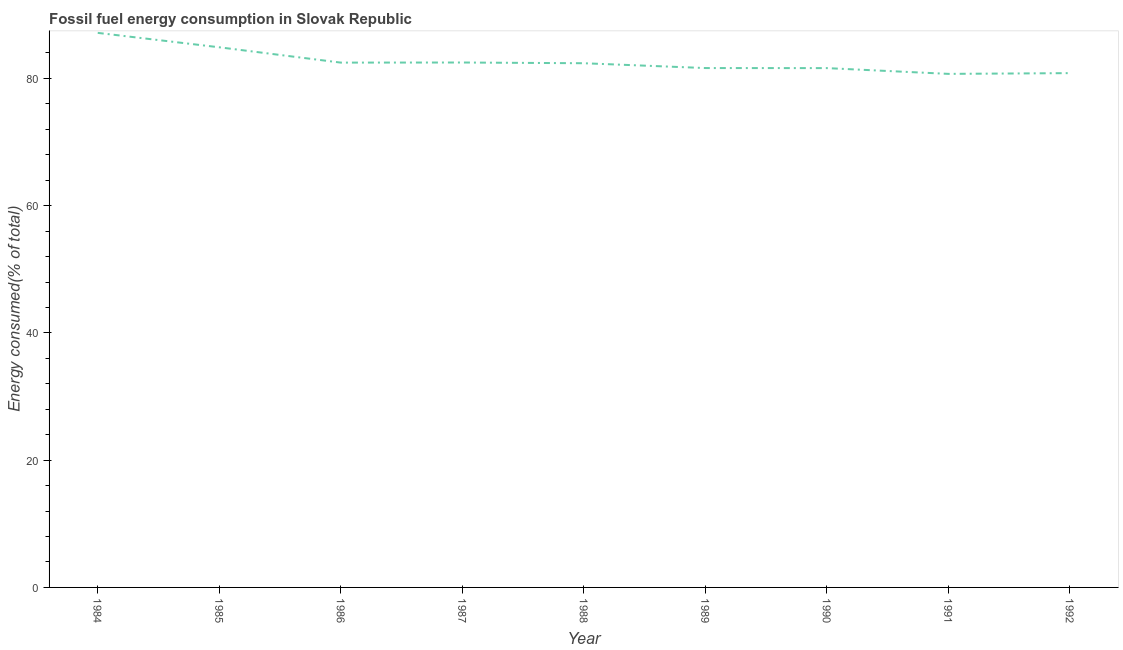What is the fossil fuel energy consumption in 1990?
Provide a succinct answer. 81.62. Across all years, what is the maximum fossil fuel energy consumption?
Give a very brief answer. 87.16. Across all years, what is the minimum fossil fuel energy consumption?
Keep it short and to the point. 80.72. In which year was the fossil fuel energy consumption maximum?
Provide a short and direct response. 1984. In which year was the fossil fuel energy consumption minimum?
Offer a very short reply. 1991. What is the sum of the fossil fuel energy consumption?
Ensure brevity in your answer.  744.24. What is the difference between the fossil fuel energy consumption in 1987 and 1992?
Give a very brief answer. 1.67. What is the average fossil fuel energy consumption per year?
Your response must be concise. 82.69. What is the median fossil fuel energy consumption?
Ensure brevity in your answer.  82.39. Do a majority of the years between 1989 and 1992 (inclusive) have fossil fuel energy consumption greater than 64 %?
Ensure brevity in your answer.  Yes. What is the ratio of the fossil fuel energy consumption in 1985 to that in 1988?
Offer a very short reply. 1.03. Is the fossil fuel energy consumption in 1988 less than that in 1989?
Provide a short and direct response. No. Is the difference between the fossil fuel energy consumption in 1987 and 1989 greater than the difference between any two years?
Your answer should be compact. No. What is the difference between the highest and the second highest fossil fuel energy consumption?
Make the answer very short. 2.27. What is the difference between the highest and the lowest fossil fuel energy consumption?
Provide a short and direct response. 6.44. Does the fossil fuel energy consumption monotonically increase over the years?
Offer a very short reply. No. How many lines are there?
Provide a succinct answer. 1. How many years are there in the graph?
Give a very brief answer. 9. What is the difference between two consecutive major ticks on the Y-axis?
Your answer should be very brief. 20. Does the graph contain any zero values?
Give a very brief answer. No. What is the title of the graph?
Your answer should be compact. Fossil fuel energy consumption in Slovak Republic. What is the label or title of the X-axis?
Give a very brief answer. Year. What is the label or title of the Y-axis?
Offer a very short reply. Energy consumed(% of total). What is the Energy consumed(% of total) in 1984?
Offer a very short reply. 87.16. What is the Energy consumed(% of total) in 1985?
Provide a succinct answer. 84.9. What is the Energy consumed(% of total) in 1986?
Make the answer very short. 82.49. What is the Energy consumed(% of total) of 1987?
Offer a terse response. 82.5. What is the Energy consumed(% of total) in 1988?
Your response must be concise. 82.39. What is the Energy consumed(% of total) in 1989?
Your response must be concise. 81.63. What is the Energy consumed(% of total) of 1990?
Provide a succinct answer. 81.62. What is the Energy consumed(% of total) in 1991?
Make the answer very short. 80.72. What is the Energy consumed(% of total) in 1992?
Provide a succinct answer. 80.83. What is the difference between the Energy consumed(% of total) in 1984 and 1985?
Make the answer very short. 2.27. What is the difference between the Energy consumed(% of total) in 1984 and 1986?
Make the answer very short. 4.67. What is the difference between the Energy consumed(% of total) in 1984 and 1987?
Ensure brevity in your answer.  4.66. What is the difference between the Energy consumed(% of total) in 1984 and 1988?
Your response must be concise. 4.77. What is the difference between the Energy consumed(% of total) in 1984 and 1989?
Give a very brief answer. 5.53. What is the difference between the Energy consumed(% of total) in 1984 and 1990?
Make the answer very short. 5.54. What is the difference between the Energy consumed(% of total) in 1984 and 1991?
Offer a very short reply. 6.44. What is the difference between the Energy consumed(% of total) in 1984 and 1992?
Offer a terse response. 6.33. What is the difference between the Energy consumed(% of total) in 1985 and 1986?
Your response must be concise. 2.41. What is the difference between the Energy consumed(% of total) in 1985 and 1987?
Provide a short and direct response. 2.39. What is the difference between the Energy consumed(% of total) in 1985 and 1988?
Ensure brevity in your answer.  2.51. What is the difference between the Energy consumed(% of total) in 1985 and 1989?
Ensure brevity in your answer.  3.26. What is the difference between the Energy consumed(% of total) in 1985 and 1990?
Ensure brevity in your answer.  3.27. What is the difference between the Energy consumed(% of total) in 1985 and 1991?
Provide a short and direct response. 4.18. What is the difference between the Energy consumed(% of total) in 1985 and 1992?
Your response must be concise. 4.06. What is the difference between the Energy consumed(% of total) in 1986 and 1987?
Offer a very short reply. -0.02. What is the difference between the Energy consumed(% of total) in 1986 and 1988?
Your answer should be very brief. 0.1. What is the difference between the Energy consumed(% of total) in 1986 and 1989?
Provide a short and direct response. 0.86. What is the difference between the Energy consumed(% of total) in 1986 and 1990?
Ensure brevity in your answer.  0.86. What is the difference between the Energy consumed(% of total) in 1986 and 1991?
Offer a terse response. 1.77. What is the difference between the Energy consumed(% of total) in 1986 and 1992?
Give a very brief answer. 1.65. What is the difference between the Energy consumed(% of total) in 1987 and 1988?
Your answer should be compact. 0.11. What is the difference between the Energy consumed(% of total) in 1987 and 1989?
Keep it short and to the point. 0.87. What is the difference between the Energy consumed(% of total) in 1987 and 1990?
Make the answer very short. 0.88. What is the difference between the Energy consumed(% of total) in 1987 and 1991?
Keep it short and to the point. 1.79. What is the difference between the Energy consumed(% of total) in 1987 and 1992?
Ensure brevity in your answer.  1.67. What is the difference between the Energy consumed(% of total) in 1988 and 1989?
Your answer should be very brief. 0.76. What is the difference between the Energy consumed(% of total) in 1988 and 1990?
Your answer should be compact. 0.77. What is the difference between the Energy consumed(% of total) in 1988 and 1991?
Your answer should be compact. 1.67. What is the difference between the Energy consumed(% of total) in 1988 and 1992?
Provide a succinct answer. 1.56. What is the difference between the Energy consumed(% of total) in 1989 and 1990?
Offer a terse response. 0.01. What is the difference between the Energy consumed(% of total) in 1989 and 1991?
Your answer should be very brief. 0.92. What is the difference between the Energy consumed(% of total) in 1989 and 1992?
Keep it short and to the point. 0.8. What is the difference between the Energy consumed(% of total) in 1990 and 1991?
Provide a succinct answer. 0.91. What is the difference between the Energy consumed(% of total) in 1990 and 1992?
Keep it short and to the point. 0.79. What is the difference between the Energy consumed(% of total) in 1991 and 1992?
Your answer should be very brief. -0.12. What is the ratio of the Energy consumed(% of total) in 1984 to that in 1986?
Make the answer very short. 1.06. What is the ratio of the Energy consumed(% of total) in 1984 to that in 1987?
Offer a very short reply. 1.06. What is the ratio of the Energy consumed(% of total) in 1984 to that in 1988?
Give a very brief answer. 1.06. What is the ratio of the Energy consumed(% of total) in 1984 to that in 1989?
Give a very brief answer. 1.07. What is the ratio of the Energy consumed(% of total) in 1984 to that in 1990?
Give a very brief answer. 1.07. What is the ratio of the Energy consumed(% of total) in 1984 to that in 1992?
Your response must be concise. 1.08. What is the ratio of the Energy consumed(% of total) in 1985 to that in 1986?
Offer a very short reply. 1.03. What is the ratio of the Energy consumed(% of total) in 1985 to that in 1987?
Ensure brevity in your answer.  1.03. What is the ratio of the Energy consumed(% of total) in 1985 to that in 1988?
Provide a short and direct response. 1.03. What is the ratio of the Energy consumed(% of total) in 1985 to that in 1989?
Offer a very short reply. 1.04. What is the ratio of the Energy consumed(% of total) in 1985 to that in 1990?
Provide a short and direct response. 1.04. What is the ratio of the Energy consumed(% of total) in 1985 to that in 1991?
Offer a very short reply. 1.05. What is the ratio of the Energy consumed(% of total) in 1986 to that in 1987?
Ensure brevity in your answer.  1. What is the ratio of the Energy consumed(% of total) in 1986 to that in 1992?
Your response must be concise. 1.02. What is the ratio of the Energy consumed(% of total) in 1987 to that in 1988?
Ensure brevity in your answer.  1. What is the ratio of the Energy consumed(% of total) in 1987 to that in 1989?
Provide a short and direct response. 1.01. What is the ratio of the Energy consumed(% of total) in 1987 to that in 1991?
Make the answer very short. 1.02. What is the ratio of the Energy consumed(% of total) in 1988 to that in 1989?
Give a very brief answer. 1.01. What is the ratio of the Energy consumed(% of total) in 1988 to that in 1990?
Offer a very short reply. 1.01. What is the ratio of the Energy consumed(% of total) in 1988 to that in 1991?
Give a very brief answer. 1.02. What is the ratio of the Energy consumed(% of total) in 1989 to that in 1991?
Keep it short and to the point. 1.01. What is the ratio of the Energy consumed(% of total) in 1990 to that in 1991?
Give a very brief answer. 1.01. 